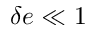Convert formula to latex. <formula><loc_0><loc_0><loc_500><loc_500>\delta e \ll 1</formula> 